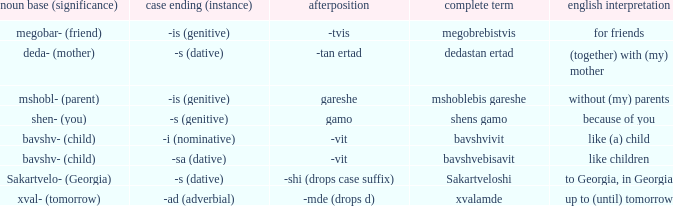What is the Full Word, when Case Suffix (case) is "-sa (dative)"? Bavshvebisavit. 